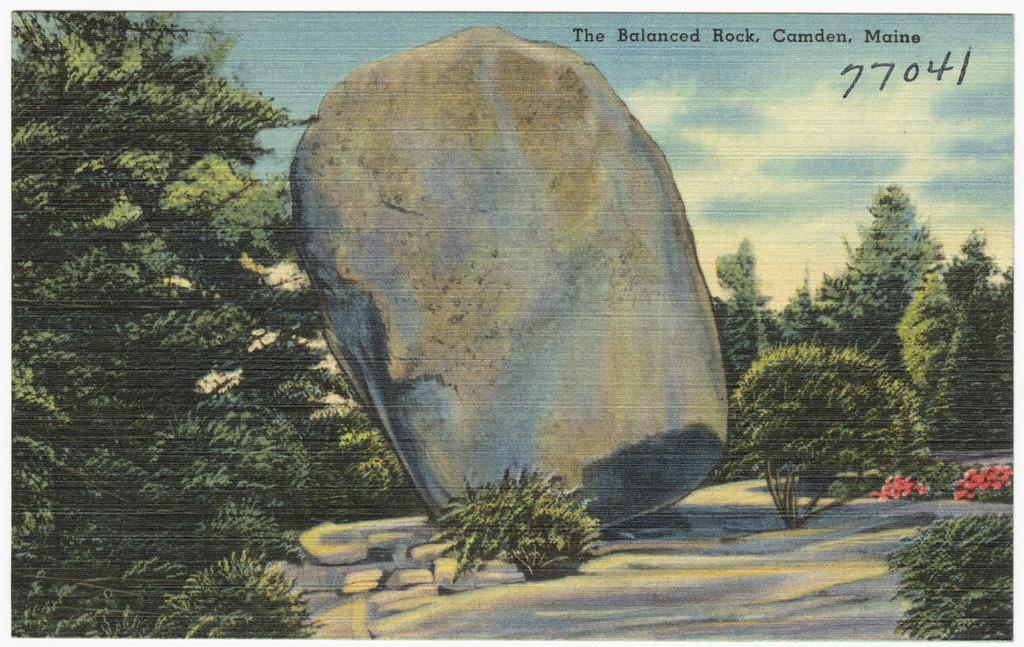<image>
Create a compact narrative representing the image presented. A drawing of a large rock named "The Balanced Rock". 